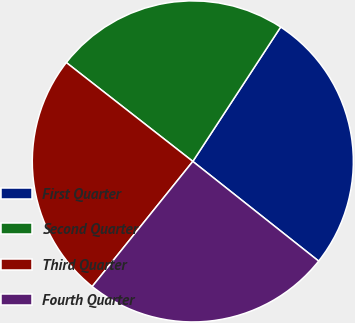Convert chart to OTSL. <chart><loc_0><loc_0><loc_500><loc_500><pie_chart><fcel>First Quarter<fcel>Second Quarter<fcel>Third Quarter<fcel>Fourth Quarter<nl><fcel>26.45%<fcel>23.66%<fcel>24.78%<fcel>25.12%<nl></chart> 